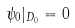Convert formula to latex. <formula><loc_0><loc_0><loc_500><loc_500>\psi _ { 0 } | _ { D _ { 0 } } = 0</formula> 